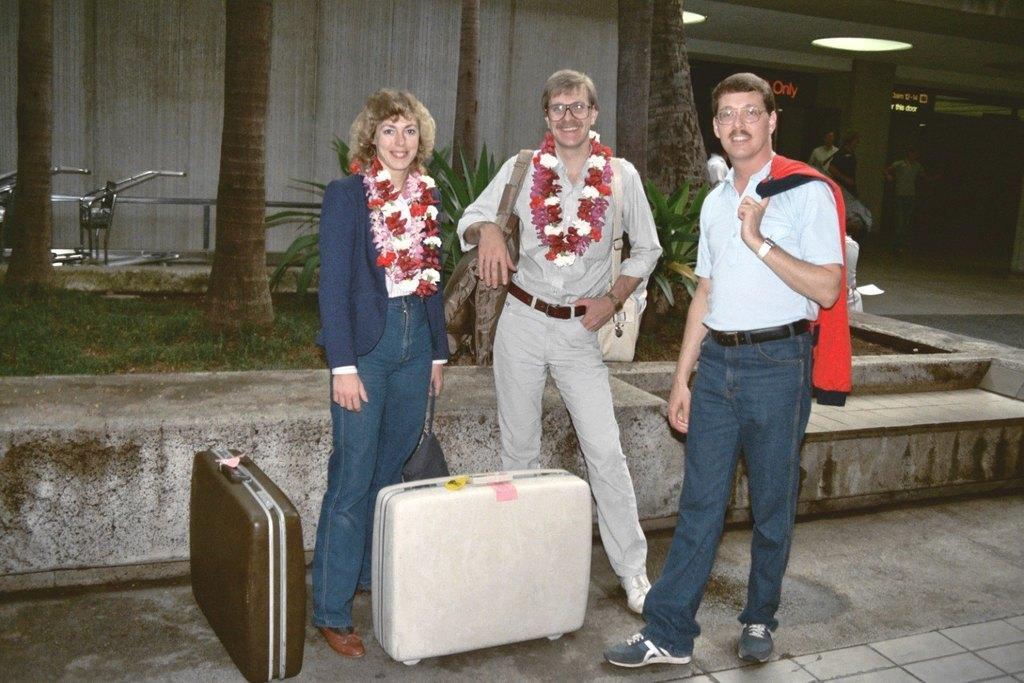In one or two sentences, can you explain what this image depicts? In this image i can see two man and a woman standing on the road in front of the man and the women there is a suitcase. At the back ground there a plant, a wall, and few members standing, at the top there is light. 